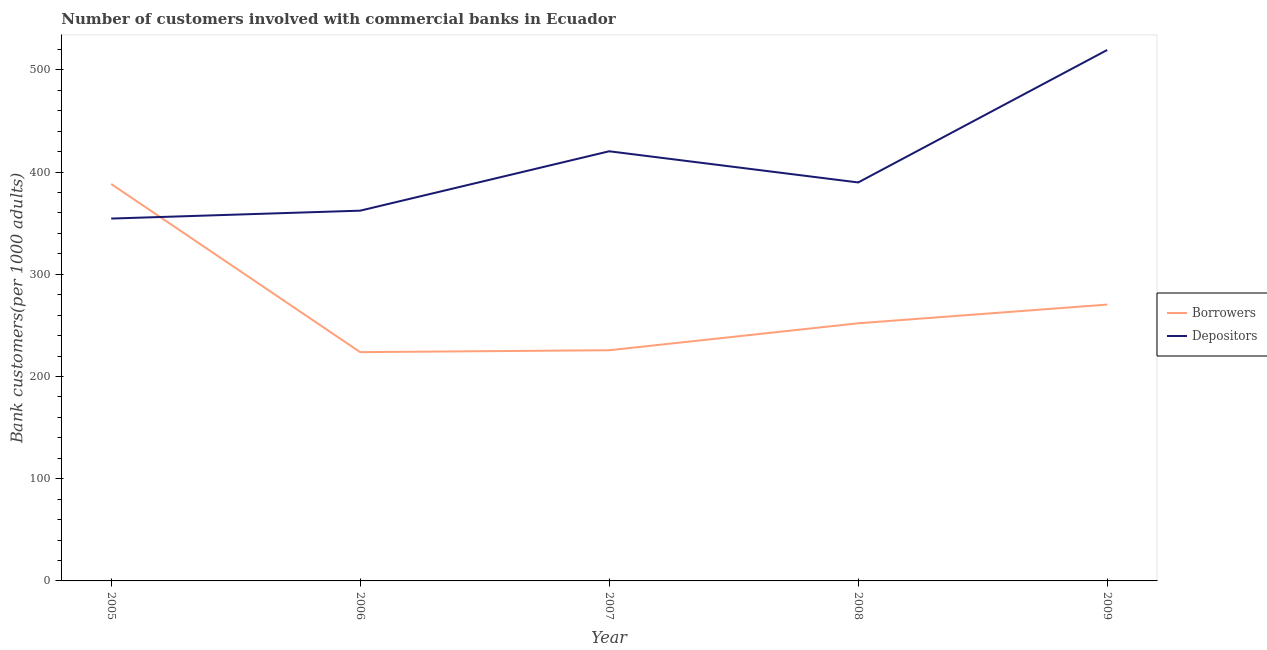What is the number of depositors in 2007?
Offer a very short reply. 420.28. Across all years, what is the maximum number of borrowers?
Your answer should be compact. 388.27. Across all years, what is the minimum number of borrowers?
Make the answer very short. 223.79. In which year was the number of depositors minimum?
Provide a short and direct response. 2005. What is the total number of depositors in the graph?
Ensure brevity in your answer.  2046.08. What is the difference between the number of borrowers in 2007 and that in 2009?
Keep it short and to the point. -44.66. What is the difference between the number of depositors in 2009 and the number of borrowers in 2007?
Provide a short and direct response. 293.71. What is the average number of depositors per year?
Ensure brevity in your answer.  409.22. In the year 2009, what is the difference between the number of borrowers and number of depositors?
Your response must be concise. -249.05. In how many years, is the number of depositors greater than 380?
Ensure brevity in your answer.  3. What is the ratio of the number of depositors in 2006 to that in 2007?
Offer a terse response. 0.86. Is the difference between the number of borrowers in 2005 and 2006 greater than the difference between the number of depositors in 2005 and 2006?
Make the answer very short. Yes. What is the difference between the highest and the second highest number of depositors?
Your answer should be compact. 99.08. What is the difference between the highest and the lowest number of depositors?
Your answer should be very brief. 164.9. Is the sum of the number of borrowers in 2006 and 2008 greater than the maximum number of depositors across all years?
Keep it short and to the point. No. Does the number of depositors monotonically increase over the years?
Keep it short and to the point. No. How many lines are there?
Keep it short and to the point. 2. How many years are there in the graph?
Your answer should be compact. 5. What is the difference between two consecutive major ticks on the Y-axis?
Your response must be concise. 100. Are the values on the major ticks of Y-axis written in scientific E-notation?
Offer a terse response. No. Does the graph contain any zero values?
Keep it short and to the point. No. Where does the legend appear in the graph?
Provide a succinct answer. Center right. What is the title of the graph?
Offer a very short reply. Number of customers involved with commercial banks in Ecuador. What is the label or title of the Y-axis?
Your answer should be very brief. Bank customers(per 1000 adults). What is the Bank customers(per 1000 adults) in Borrowers in 2005?
Your answer should be compact. 388.27. What is the Bank customers(per 1000 adults) of Depositors in 2005?
Offer a very short reply. 354.46. What is the Bank customers(per 1000 adults) of Borrowers in 2006?
Give a very brief answer. 223.79. What is the Bank customers(per 1000 adults) of Depositors in 2006?
Ensure brevity in your answer.  362.19. What is the Bank customers(per 1000 adults) of Borrowers in 2007?
Give a very brief answer. 225.65. What is the Bank customers(per 1000 adults) of Depositors in 2007?
Make the answer very short. 420.28. What is the Bank customers(per 1000 adults) in Borrowers in 2008?
Offer a terse response. 252.02. What is the Bank customers(per 1000 adults) of Depositors in 2008?
Your answer should be compact. 389.78. What is the Bank customers(per 1000 adults) of Borrowers in 2009?
Give a very brief answer. 270.31. What is the Bank customers(per 1000 adults) in Depositors in 2009?
Your response must be concise. 519.36. Across all years, what is the maximum Bank customers(per 1000 adults) in Borrowers?
Offer a very short reply. 388.27. Across all years, what is the maximum Bank customers(per 1000 adults) of Depositors?
Give a very brief answer. 519.36. Across all years, what is the minimum Bank customers(per 1000 adults) in Borrowers?
Give a very brief answer. 223.79. Across all years, what is the minimum Bank customers(per 1000 adults) of Depositors?
Provide a succinct answer. 354.46. What is the total Bank customers(per 1000 adults) of Borrowers in the graph?
Provide a succinct answer. 1360.04. What is the total Bank customers(per 1000 adults) in Depositors in the graph?
Provide a succinct answer. 2046.08. What is the difference between the Bank customers(per 1000 adults) in Borrowers in 2005 and that in 2006?
Provide a succinct answer. 164.48. What is the difference between the Bank customers(per 1000 adults) in Depositors in 2005 and that in 2006?
Keep it short and to the point. -7.72. What is the difference between the Bank customers(per 1000 adults) of Borrowers in 2005 and that in 2007?
Provide a short and direct response. 162.61. What is the difference between the Bank customers(per 1000 adults) of Depositors in 2005 and that in 2007?
Ensure brevity in your answer.  -65.82. What is the difference between the Bank customers(per 1000 adults) in Borrowers in 2005 and that in 2008?
Your answer should be compact. 136.25. What is the difference between the Bank customers(per 1000 adults) in Depositors in 2005 and that in 2008?
Provide a short and direct response. -35.32. What is the difference between the Bank customers(per 1000 adults) in Borrowers in 2005 and that in 2009?
Offer a terse response. 117.96. What is the difference between the Bank customers(per 1000 adults) of Depositors in 2005 and that in 2009?
Make the answer very short. -164.9. What is the difference between the Bank customers(per 1000 adults) of Borrowers in 2006 and that in 2007?
Keep it short and to the point. -1.87. What is the difference between the Bank customers(per 1000 adults) in Depositors in 2006 and that in 2007?
Offer a terse response. -58.09. What is the difference between the Bank customers(per 1000 adults) in Borrowers in 2006 and that in 2008?
Ensure brevity in your answer.  -28.24. What is the difference between the Bank customers(per 1000 adults) in Depositors in 2006 and that in 2008?
Provide a succinct answer. -27.6. What is the difference between the Bank customers(per 1000 adults) in Borrowers in 2006 and that in 2009?
Your response must be concise. -46.52. What is the difference between the Bank customers(per 1000 adults) in Depositors in 2006 and that in 2009?
Your answer should be very brief. -157.18. What is the difference between the Bank customers(per 1000 adults) of Borrowers in 2007 and that in 2008?
Provide a short and direct response. -26.37. What is the difference between the Bank customers(per 1000 adults) in Depositors in 2007 and that in 2008?
Your response must be concise. 30.5. What is the difference between the Bank customers(per 1000 adults) in Borrowers in 2007 and that in 2009?
Offer a very short reply. -44.66. What is the difference between the Bank customers(per 1000 adults) of Depositors in 2007 and that in 2009?
Provide a short and direct response. -99.08. What is the difference between the Bank customers(per 1000 adults) in Borrowers in 2008 and that in 2009?
Keep it short and to the point. -18.29. What is the difference between the Bank customers(per 1000 adults) in Depositors in 2008 and that in 2009?
Your answer should be very brief. -129.58. What is the difference between the Bank customers(per 1000 adults) in Borrowers in 2005 and the Bank customers(per 1000 adults) in Depositors in 2006?
Give a very brief answer. 26.08. What is the difference between the Bank customers(per 1000 adults) of Borrowers in 2005 and the Bank customers(per 1000 adults) of Depositors in 2007?
Offer a very short reply. -32.01. What is the difference between the Bank customers(per 1000 adults) in Borrowers in 2005 and the Bank customers(per 1000 adults) in Depositors in 2008?
Your answer should be very brief. -1.51. What is the difference between the Bank customers(per 1000 adults) in Borrowers in 2005 and the Bank customers(per 1000 adults) in Depositors in 2009?
Keep it short and to the point. -131.1. What is the difference between the Bank customers(per 1000 adults) of Borrowers in 2006 and the Bank customers(per 1000 adults) of Depositors in 2007?
Your answer should be compact. -196.49. What is the difference between the Bank customers(per 1000 adults) in Borrowers in 2006 and the Bank customers(per 1000 adults) in Depositors in 2008?
Give a very brief answer. -166. What is the difference between the Bank customers(per 1000 adults) of Borrowers in 2006 and the Bank customers(per 1000 adults) of Depositors in 2009?
Your response must be concise. -295.58. What is the difference between the Bank customers(per 1000 adults) of Borrowers in 2007 and the Bank customers(per 1000 adults) of Depositors in 2008?
Offer a terse response. -164.13. What is the difference between the Bank customers(per 1000 adults) in Borrowers in 2007 and the Bank customers(per 1000 adults) in Depositors in 2009?
Provide a succinct answer. -293.71. What is the difference between the Bank customers(per 1000 adults) in Borrowers in 2008 and the Bank customers(per 1000 adults) in Depositors in 2009?
Make the answer very short. -267.34. What is the average Bank customers(per 1000 adults) of Borrowers per year?
Your response must be concise. 272.01. What is the average Bank customers(per 1000 adults) of Depositors per year?
Your answer should be compact. 409.22. In the year 2005, what is the difference between the Bank customers(per 1000 adults) of Borrowers and Bank customers(per 1000 adults) of Depositors?
Keep it short and to the point. 33.81. In the year 2006, what is the difference between the Bank customers(per 1000 adults) of Borrowers and Bank customers(per 1000 adults) of Depositors?
Keep it short and to the point. -138.4. In the year 2007, what is the difference between the Bank customers(per 1000 adults) in Borrowers and Bank customers(per 1000 adults) in Depositors?
Your answer should be compact. -194.63. In the year 2008, what is the difference between the Bank customers(per 1000 adults) of Borrowers and Bank customers(per 1000 adults) of Depositors?
Your response must be concise. -137.76. In the year 2009, what is the difference between the Bank customers(per 1000 adults) in Borrowers and Bank customers(per 1000 adults) in Depositors?
Make the answer very short. -249.05. What is the ratio of the Bank customers(per 1000 adults) in Borrowers in 2005 to that in 2006?
Make the answer very short. 1.74. What is the ratio of the Bank customers(per 1000 adults) of Depositors in 2005 to that in 2006?
Your answer should be compact. 0.98. What is the ratio of the Bank customers(per 1000 adults) in Borrowers in 2005 to that in 2007?
Offer a terse response. 1.72. What is the ratio of the Bank customers(per 1000 adults) in Depositors in 2005 to that in 2007?
Keep it short and to the point. 0.84. What is the ratio of the Bank customers(per 1000 adults) of Borrowers in 2005 to that in 2008?
Provide a short and direct response. 1.54. What is the ratio of the Bank customers(per 1000 adults) of Depositors in 2005 to that in 2008?
Your answer should be very brief. 0.91. What is the ratio of the Bank customers(per 1000 adults) in Borrowers in 2005 to that in 2009?
Offer a very short reply. 1.44. What is the ratio of the Bank customers(per 1000 adults) of Depositors in 2005 to that in 2009?
Make the answer very short. 0.68. What is the ratio of the Bank customers(per 1000 adults) of Borrowers in 2006 to that in 2007?
Your answer should be compact. 0.99. What is the ratio of the Bank customers(per 1000 adults) in Depositors in 2006 to that in 2007?
Provide a short and direct response. 0.86. What is the ratio of the Bank customers(per 1000 adults) in Borrowers in 2006 to that in 2008?
Keep it short and to the point. 0.89. What is the ratio of the Bank customers(per 1000 adults) of Depositors in 2006 to that in 2008?
Provide a short and direct response. 0.93. What is the ratio of the Bank customers(per 1000 adults) in Borrowers in 2006 to that in 2009?
Your response must be concise. 0.83. What is the ratio of the Bank customers(per 1000 adults) of Depositors in 2006 to that in 2009?
Your answer should be compact. 0.7. What is the ratio of the Bank customers(per 1000 adults) of Borrowers in 2007 to that in 2008?
Provide a succinct answer. 0.9. What is the ratio of the Bank customers(per 1000 adults) in Depositors in 2007 to that in 2008?
Provide a short and direct response. 1.08. What is the ratio of the Bank customers(per 1000 adults) in Borrowers in 2007 to that in 2009?
Provide a succinct answer. 0.83. What is the ratio of the Bank customers(per 1000 adults) of Depositors in 2007 to that in 2009?
Give a very brief answer. 0.81. What is the ratio of the Bank customers(per 1000 adults) in Borrowers in 2008 to that in 2009?
Provide a short and direct response. 0.93. What is the ratio of the Bank customers(per 1000 adults) in Depositors in 2008 to that in 2009?
Offer a very short reply. 0.75. What is the difference between the highest and the second highest Bank customers(per 1000 adults) of Borrowers?
Ensure brevity in your answer.  117.96. What is the difference between the highest and the second highest Bank customers(per 1000 adults) in Depositors?
Your answer should be very brief. 99.08. What is the difference between the highest and the lowest Bank customers(per 1000 adults) in Borrowers?
Make the answer very short. 164.48. What is the difference between the highest and the lowest Bank customers(per 1000 adults) in Depositors?
Your answer should be compact. 164.9. 